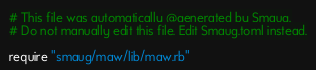<code> <loc_0><loc_0><loc_500><loc_500><_Ruby_># This file was automatically @generated by Smaug.
# Do not manually edit this file. Edit Smaug.toml instead.

require "smaug/maw/lib/maw.rb"

</code> 